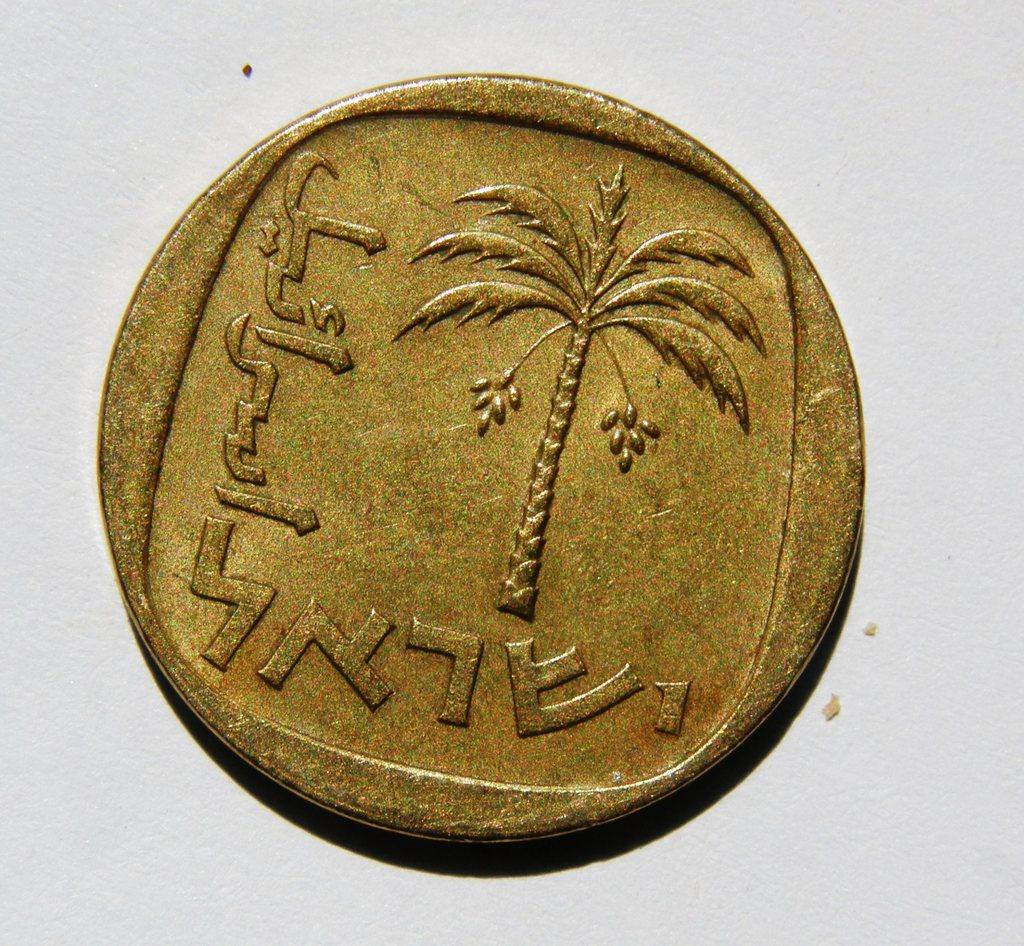<image>
Give a short and clear explanation of the subsequent image. a golden coin with a palm tree and arabic writing sits against a grey background 